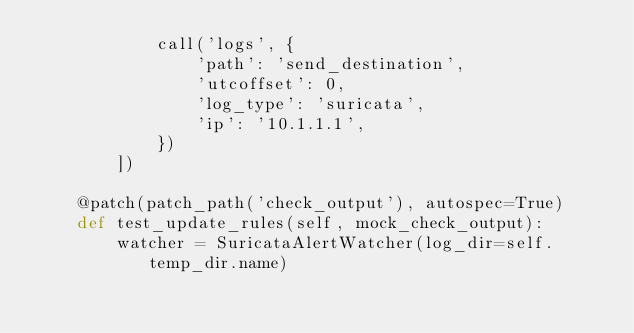<code> <loc_0><loc_0><loc_500><loc_500><_Python_>            call('logs', {
                'path': 'send_destination',
                'utcoffset': 0,
                'log_type': 'suricata',
                'ip': '10.1.1.1',
            })
        ])

    @patch(patch_path('check_output'), autospec=True)
    def test_update_rules(self, mock_check_output):
        watcher = SuricataAlertWatcher(log_dir=self.temp_dir.name)</code> 